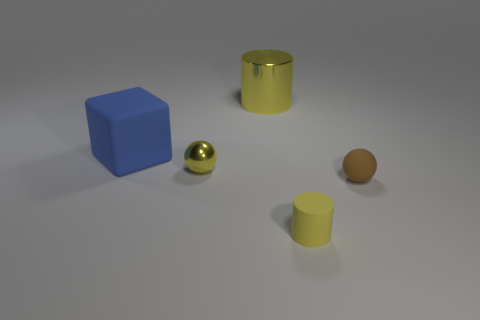Add 3 small yellow objects. How many objects exist? 8 Subtract all brown balls. How many balls are left? 1 Subtract 1 balls. How many balls are left? 1 Subtract all blue cylinders. Subtract all green spheres. How many cylinders are left? 2 Subtract all cyan balls. How many brown blocks are left? 0 Subtract 0 brown cubes. How many objects are left? 5 Subtract all blocks. How many objects are left? 4 Subtract all small yellow matte blocks. Subtract all big yellow objects. How many objects are left? 4 Add 2 blocks. How many blocks are left? 3 Add 3 large cubes. How many large cubes exist? 4 